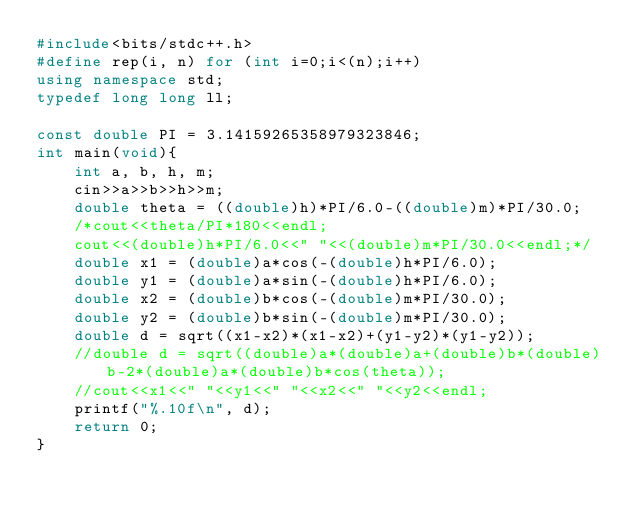<code> <loc_0><loc_0><loc_500><loc_500><_C++_>#include<bits/stdc++.h>
#define rep(i, n) for (int i=0;i<(n);i++)
using namespace std;
typedef long long ll;
 
const double PI = 3.14159265358979323846;
int main(void){
    int a, b, h, m;
    cin>>a>>b>>h>>m;
    double theta = ((double)h)*PI/6.0-((double)m)*PI/30.0;
    /*cout<<theta/PI*180<<endl;
    cout<<(double)h*PI/6.0<<" "<<(double)m*PI/30.0<<endl;*/
    double x1 = (double)a*cos(-(double)h*PI/6.0);
    double y1 = (double)a*sin(-(double)h*PI/6.0);
    double x2 = (double)b*cos(-(double)m*PI/30.0);
    double y2 = (double)b*sin(-(double)m*PI/30.0);
    double d = sqrt((x1-x2)*(x1-x2)+(y1-y2)*(y1-y2));
    //double d = sqrt((double)a*(double)a+(double)b*(double)b-2*(double)a*(double)b*cos(theta));
    //cout<<x1<<" "<<y1<<" "<<x2<<" "<<y2<<endl;
    printf("%.10f\n", d);
    return 0;
}</code> 